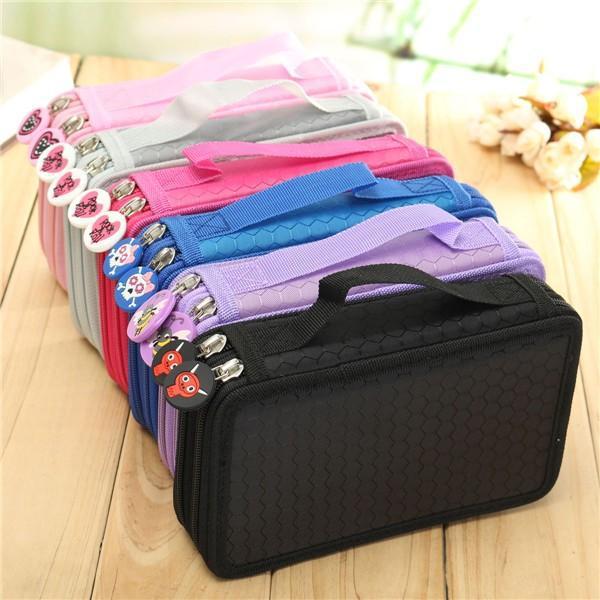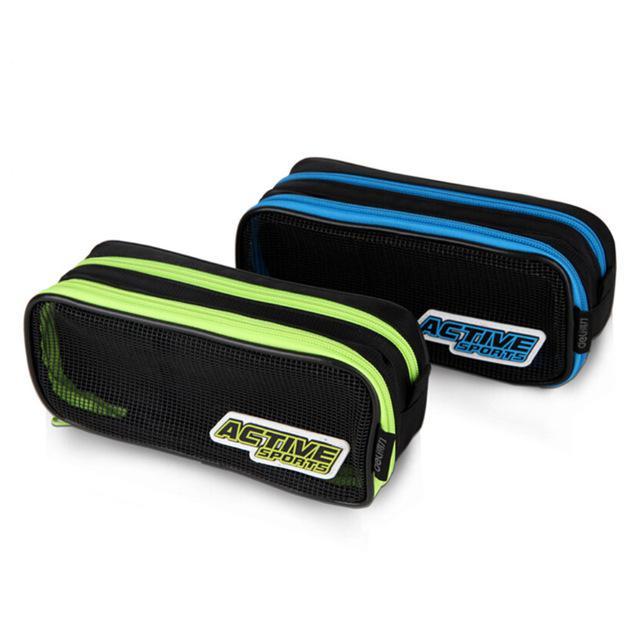The first image is the image on the left, the second image is the image on the right. Evaluate the accuracy of this statement regarding the images: "The left image shows exactly one case.". Is it true? Answer yes or no. No. The first image is the image on the left, the second image is the image on the right. For the images displayed, is the sentence "There is an image that has an open and a closed case" factually correct? Answer yes or no. No. The first image is the image on the left, the second image is the image on the right. Considering the images on both sides, is "At least one image contains a single pencil case." valid? Answer yes or no. No. 